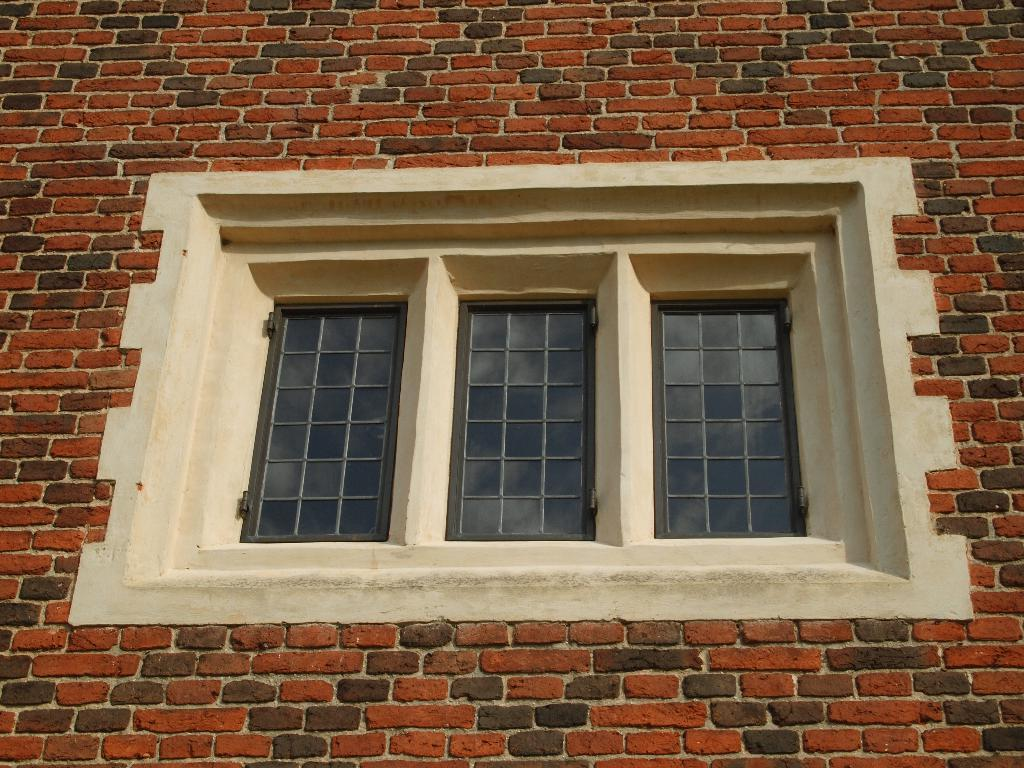What type of structure is visible in the image? There is a wall in the image. Are there any openings in the wall? Yes, there are windows in the image. What material can be seen in the image? There are metal rods in the image. What can be seen in the mirror reflection? The mirror reflection shows clouds. Is there a tub filled with water during the record-breaking rainstorm in the image? There is no tub or rainstorm present in the image. 